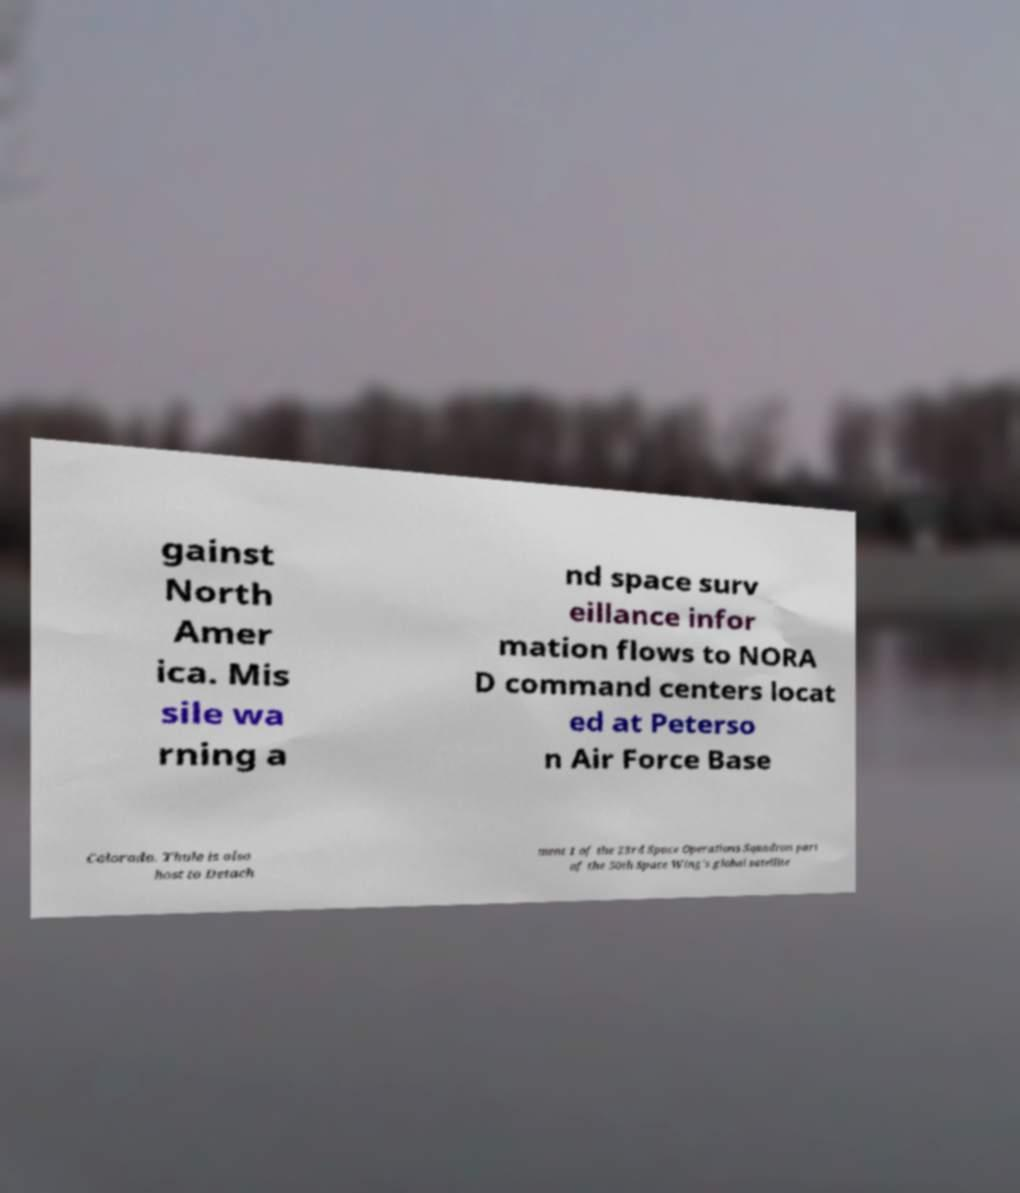I need the written content from this picture converted into text. Can you do that? gainst North Amer ica. Mis sile wa rning a nd space surv eillance infor mation flows to NORA D command centers locat ed at Peterso n Air Force Base Colorado. Thule is also host to Detach ment 1 of the 23rd Space Operations Squadron part of the 50th Space Wing's global satellite 